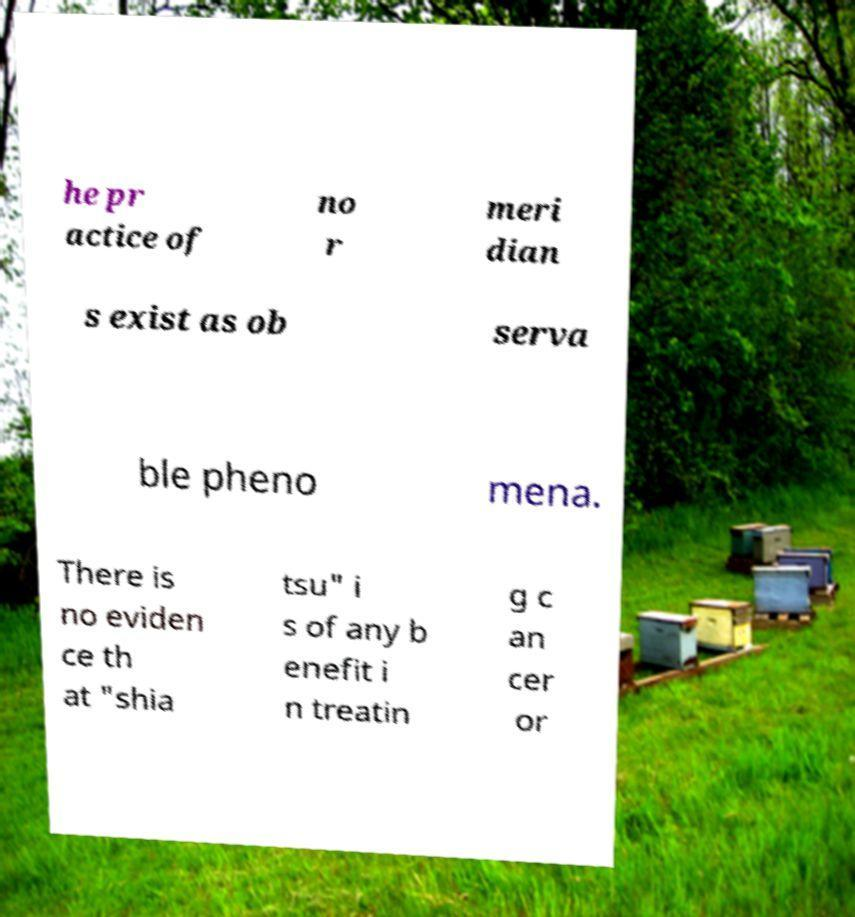For documentation purposes, I need the text within this image transcribed. Could you provide that? he pr actice of no r meri dian s exist as ob serva ble pheno mena. There is no eviden ce th at "shia tsu" i s of any b enefit i n treatin g c an cer or 